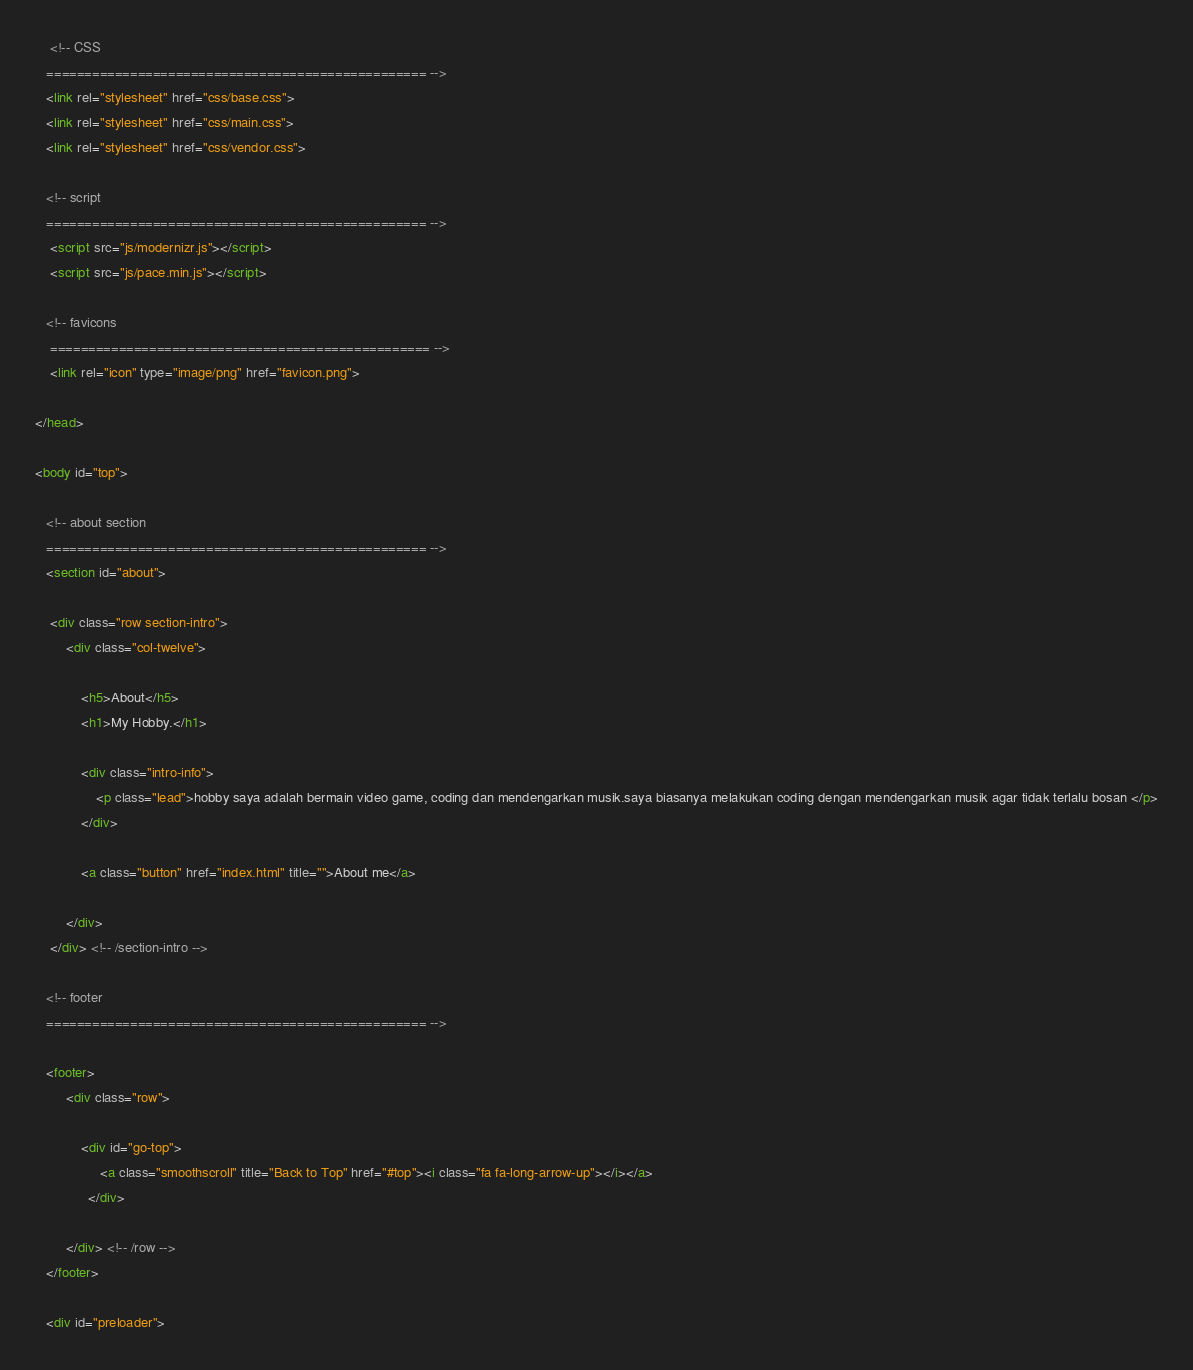Convert code to text. <code><loc_0><loc_0><loc_500><loc_500><_HTML_> 	<!-- CSS
   ================================================== -->
   <link rel="stylesheet" href="css/base.css">  
   <link rel="stylesheet" href="css/main.css">
   <link rel="stylesheet" href="css/vendor.css">     

   <!-- script
   ================================================== -->   
	<script src="js/modernizr.js"></script>
	<script src="js/pace.min.js"></script>

   <!-- favicons
	================================================== -->
	<link rel="icon" type="image/png" href="favicon.png">

</head>

<body id="top">

   <!-- about section
   ================================================== -->
   <section id="about">  

   	<div class="row section-intro">
   		<div class="col-twelve">

   			<h5>About</h5>
   			<h1>My Hobby.</h1>

   			<div class="intro-info">
   				<p class="lead">hobby saya adalah bermain video game, coding dan mendengarkan musik.saya biasanya melakukan coding dengan mendengarkan musik agar tidak terlalu bosan </p>
   			</div>   

			<a class="button" href="index.html" title="">About me</a>			
			
   		</div>   		
   	</div> <!-- /section-intro -->

   <!-- footer
   ================================================== -->

   <footer>
     	<div class="row">

	      	<div id="go-top">
		         <a class="smoothscroll" title="Back to Top" href="#top"><i class="fa fa-long-arrow-up"></i></a>
		      </div>

      	</div> <!-- /row -->     	
   </footer>  

   <div id="preloader"> </code> 